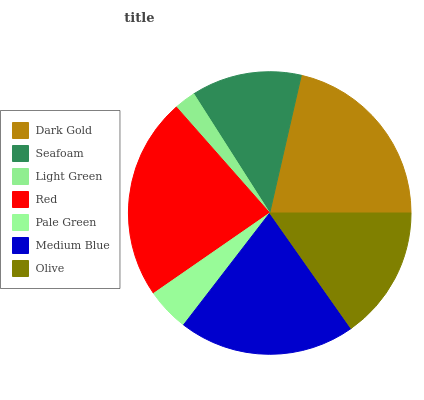Is Light Green the minimum?
Answer yes or no. Yes. Is Red the maximum?
Answer yes or no. Yes. Is Seafoam the minimum?
Answer yes or no. No. Is Seafoam the maximum?
Answer yes or no. No. Is Dark Gold greater than Seafoam?
Answer yes or no. Yes. Is Seafoam less than Dark Gold?
Answer yes or no. Yes. Is Seafoam greater than Dark Gold?
Answer yes or no. No. Is Dark Gold less than Seafoam?
Answer yes or no. No. Is Olive the high median?
Answer yes or no. Yes. Is Olive the low median?
Answer yes or no. Yes. Is Red the high median?
Answer yes or no. No. Is Red the low median?
Answer yes or no. No. 